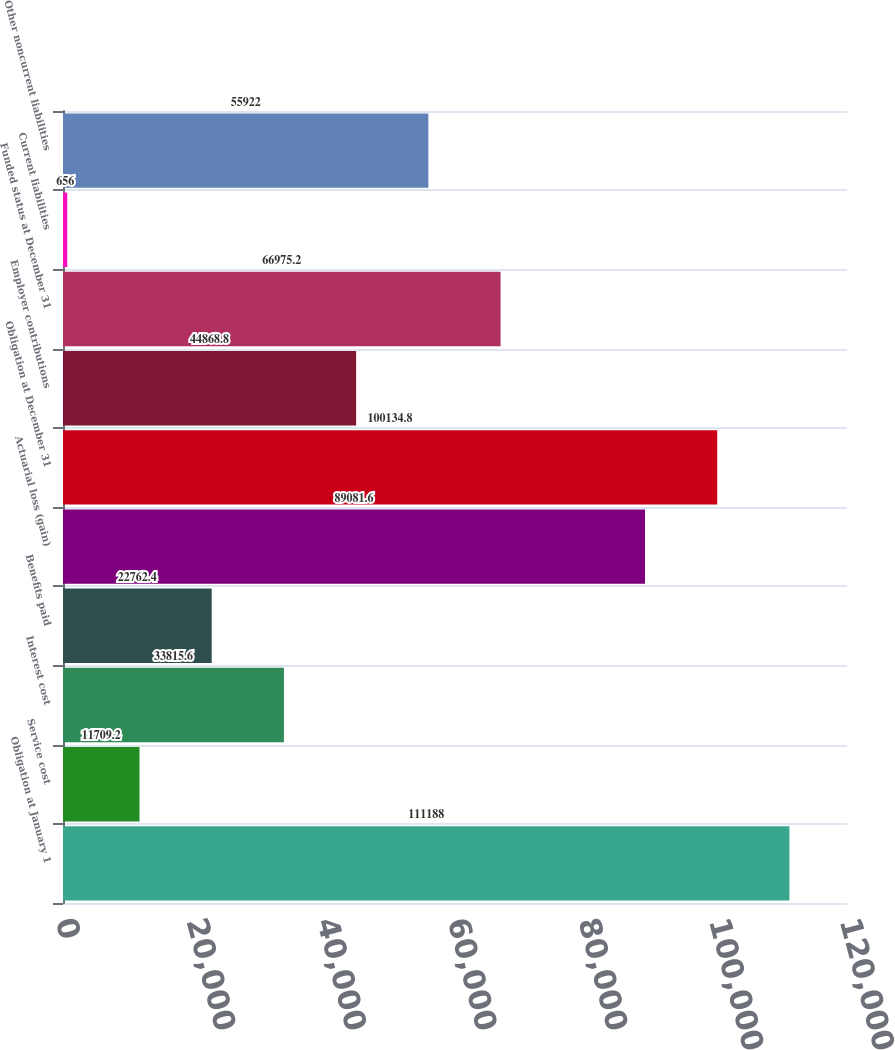Convert chart to OTSL. <chart><loc_0><loc_0><loc_500><loc_500><bar_chart><fcel>Obligation at January 1<fcel>Service cost<fcel>Interest cost<fcel>Benefits paid<fcel>Actuarial loss (gain)<fcel>Obligation at December 31<fcel>Employer contributions<fcel>Funded status at December 31<fcel>Current liabilities<fcel>Other noncurrent liabilities<nl><fcel>111188<fcel>11709.2<fcel>33815.6<fcel>22762.4<fcel>89081.6<fcel>100135<fcel>44868.8<fcel>66975.2<fcel>656<fcel>55922<nl></chart> 